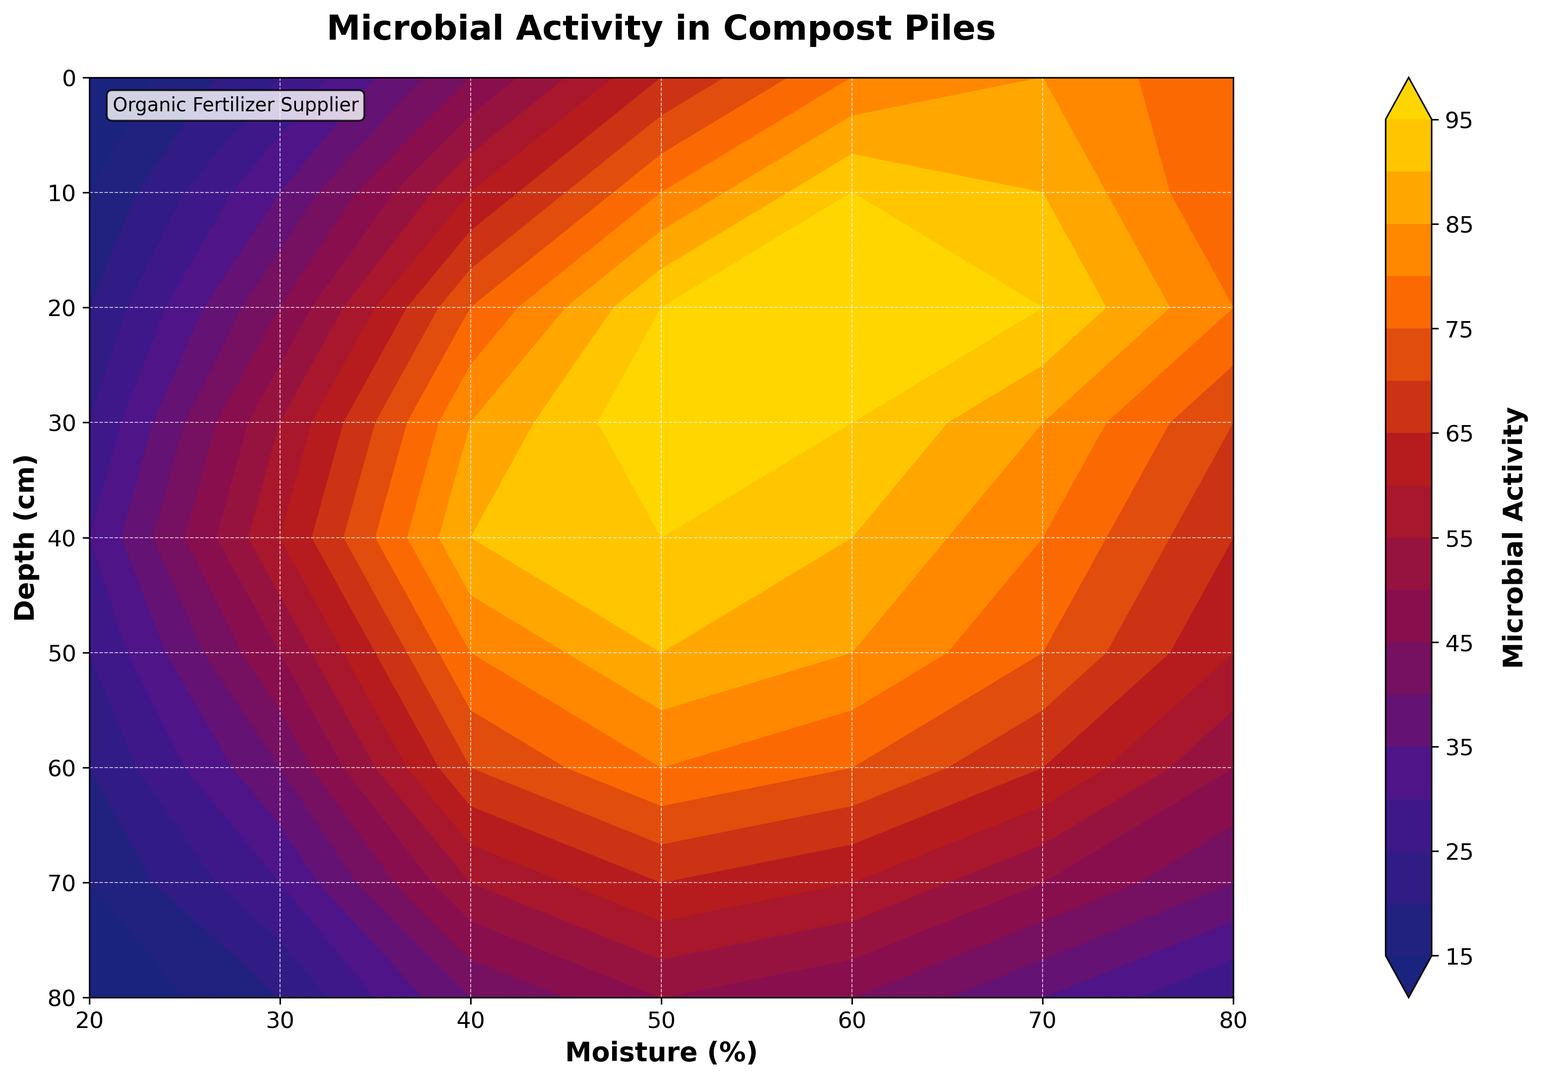what is the microbial activity at 30 cm depth and 50% moisture? First, locate the point where the depth is 30 cm and moisture is 50%. Then, read the microbial activity value from the contour lines.
Answer: 100 How does microbial activity change as depth increases from 10 cm to 50 cm at 60% moisture level? Check the microbial activity at 10 cm (95) and 50 cm (85) on the 60% moisture line.
Answer: Decreases At what moisture level does 20 cm depth show peak microbial activity? Identify the highest value on the 20 cm depth line, which is 100, seen at 60% moisture.
Answer: 60% Compare the microbial activity at 20% moisture for 0 cm and 70 cm depth. Locate the microbial activity for 0 cm depth (10) and 70 cm depth (15) at 20% moisture. Then compare these values.
Answer: 70 cm is higher What is the average microbial activity at 20 cm depth across all moisture levels? Sum the microbial activities at 20 cm depth (20, 45, 75, 95, 100, 95, 80) and divide by the number of points (7). The sum is 510, and the average is 510/7.
Answer: 73 Is the microbial activity higher at 40% moisture and 60 cm depth or at 70% moisture and 50 cm depth? Compare the microbial activities at 40% moisture, 60 cm depth (70) and 70% moisture, 50 cm depth (75).
Answer: 50 cm and 70% What depth has the lowest microbial activity at 70% moisture level? Identify the lowest value on the 70% moisture line, which is 35, seen at 80 cm depth.
Answer: 80 cm What range of depths shows microbial activity greater than 90 at any moisture level? Check all depths where any point exceeds 90. Depths 10 cm to 40 cm all show microbial activity greater than 90 for some moisture levels.
Answer: 10 cm to 40 cm 